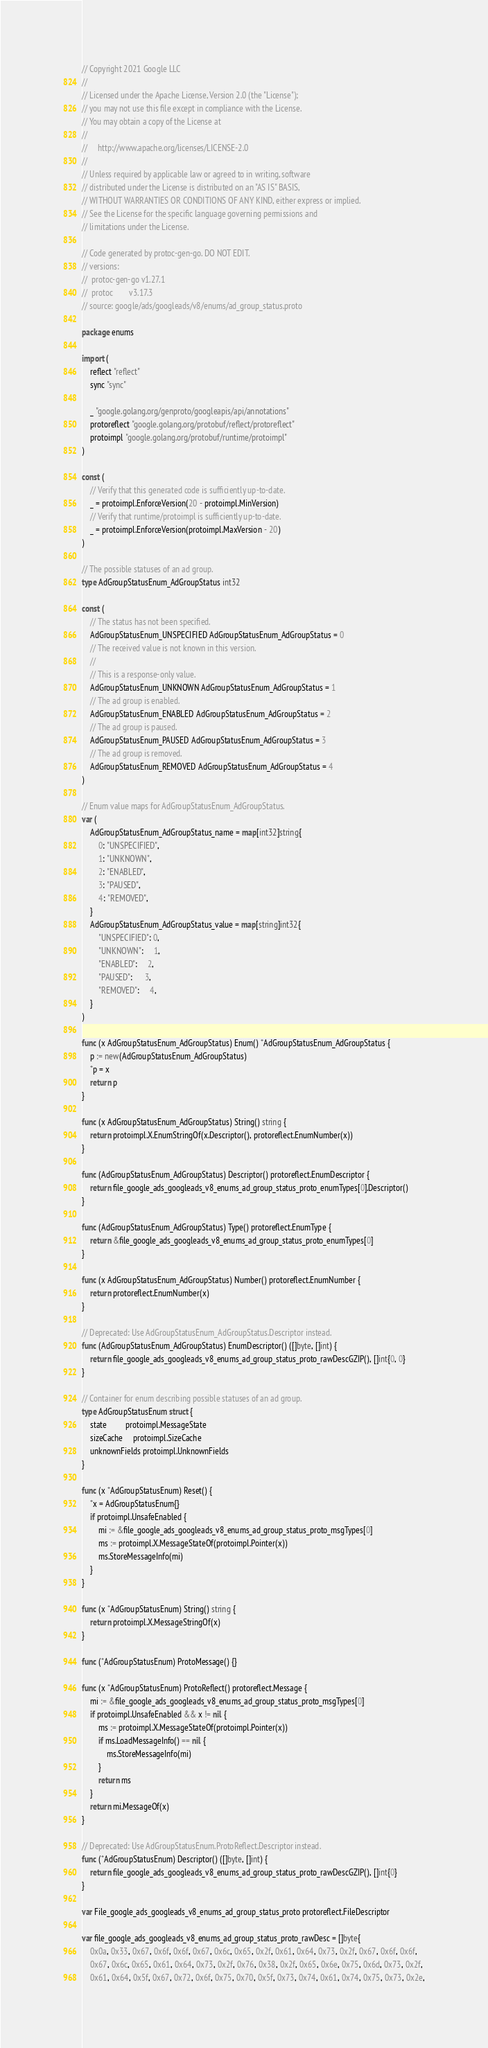Convert code to text. <code><loc_0><loc_0><loc_500><loc_500><_Go_>// Copyright 2021 Google LLC
//
// Licensed under the Apache License, Version 2.0 (the "License");
// you may not use this file except in compliance with the License.
// You may obtain a copy of the License at
//
//     http://www.apache.org/licenses/LICENSE-2.0
//
// Unless required by applicable law or agreed to in writing, software
// distributed under the License is distributed on an "AS IS" BASIS,
// WITHOUT WARRANTIES OR CONDITIONS OF ANY KIND, either express or implied.
// See the License for the specific language governing permissions and
// limitations under the License.

// Code generated by protoc-gen-go. DO NOT EDIT.
// versions:
// 	protoc-gen-go v1.27.1
// 	protoc        v3.17.3
// source: google/ads/googleads/v8/enums/ad_group_status.proto

package enums

import (
	reflect "reflect"
	sync "sync"

	_ "google.golang.org/genproto/googleapis/api/annotations"
	protoreflect "google.golang.org/protobuf/reflect/protoreflect"
	protoimpl "google.golang.org/protobuf/runtime/protoimpl"
)

const (
	// Verify that this generated code is sufficiently up-to-date.
	_ = protoimpl.EnforceVersion(20 - protoimpl.MinVersion)
	// Verify that runtime/protoimpl is sufficiently up-to-date.
	_ = protoimpl.EnforceVersion(protoimpl.MaxVersion - 20)
)

// The possible statuses of an ad group.
type AdGroupStatusEnum_AdGroupStatus int32

const (
	// The status has not been specified.
	AdGroupStatusEnum_UNSPECIFIED AdGroupStatusEnum_AdGroupStatus = 0
	// The received value is not known in this version.
	//
	// This is a response-only value.
	AdGroupStatusEnum_UNKNOWN AdGroupStatusEnum_AdGroupStatus = 1
	// The ad group is enabled.
	AdGroupStatusEnum_ENABLED AdGroupStatusEnum_AdGroupStatus = 2
	// The ad group is paused.
	AdGroupStatusEnum_PAUSED AdGroupStatusEnum_AdGroupStatus = 3
	// The ad group is removed.
	AdGroupStatusEnum_REMOVED AdGroupStatusEnum_AdGroupStatus = 4
)

// Enum value maps for AdGroupStatusEnum_AdGroupStatus.
var (
	AdGroupStatusEnum_AdGroupStatus_name = map[int32]string{
		0: "UNSPECIFIED",
		1: "UNKNOWN",
		2: "ENABLED",
		3: "PAUSED",
		4: "REMOVED",
	}
	AdGroupStatusEnum_AdGroupStatus_value = map[string]int32{
		"UNSPECIFIED": 0,
		"UNKNOWN":     1,
		"ENABLED":     2,
		"PAUSED":      3,
		"REMOVED":     4,
	}
)

func (x AdGroupStatusEnum_AdGroupStatus) Enum() *AdGroupStatusEnum_AdGroupStatus {
	p := new(AdGroupStatusEnum_AdGroupStatus)
	*p = x
	return p
}

func (x AdGroupStatusEnum_AdGroupStatus) String() string {
	return protoimpl.X.EnumStringOf(x.Descriptor(), protoreflect.EnumNumber(x))
}

func (AdGroupStatusEnum_AdGroupStatus) Descriptor() protoreflect.EnumDescriptor {
	return file_google_ads_googleads_v8_enums_ad_group_status_proto_enumTypes[0].Descriptor()
}

func (AdGroupStatusEnum_AdGroupStatus) Type() protoreflect.EnumType {
	return &file_google_ads_googleads_v8_enums_ad_group_status_proto_enumTypes[0]
}

func (x AdGroupStatusEnum_AdGroupStatus) Number() protoreflect.EnumNumber {
	return protoreflect.EnumNumber(x)
}

// Deprecated: Use AdGroupStatusEnum_AdGroupStatus.Descriptor instead.
func (AdGroupStatusEnum_AdGroupStatus) EnumDescriptor() ([]byte, []int) {
	return file_google_ads_googleads_v8_enums_ad_group_status_proto_rawDescGZIP(), []int{0, 0}
}

// Container for enum describing possible statuses of an ad group.
type AdGroupStatusEnum struct {
	state         protoimpl.MessageState
	sizeCache     protoimpl.SizeCache
	unknownFields protoimpl.UnknownFields
}

func (x *AdGroupStatusEnum) Reset() {
	*x = AdGroupStatusEnum{}
	if protoimpl.UnsafeEnabled {
		mi := &file_google_ads_googleads_v8_enums_ad_group_status_proto_msgTypes[0]
		ms := protoimpl.X.MessageStateOf(protoimpl.Pointer(x))
		ms.StoreMessageInfo(mi)
	}
}

func (x *AdGroupStatusEnum) String() string {
	return protoimpl.X.MessageStringOf(x)
}

func (*AdGroupStatusEnum) ProtoMessage() {}

func (x *AdGroupStatusEnum) ProtoReflect() protoreflect.Message {
	mi := &file_google_ads_googleads_v8_enums_ad_group_status_proto_msgTypes[0]
	if protoimpl.UnsafeEnabled && x != nil {
		ms := protoimpl.X.MessageStateOf(protoimpl.Pointer(x))
		if ms.LoadMessageInfo() == nil {
			ms.StoreMessageInfo(mi)
		}
		return ms
	}
	return mi.MessageOf(x)
}

// Deprecated: Use AdGroupStatusEnum.ProtoReflect.Descriptor instead.
func (*AdGroupStatusEnum) Descriptor() ([]byte, []int) {
	return file_google_ads_googleads_v8_enums_ad_group_status_proto_rawDescGZIP(), []int{0}
}

var File_google_ads_googleads_v8_enums_ad_group_status_proto protoreflect.FileDescriptor

var file_google_ads_googleads_v8_enums_ad_group_status_proto_rawDesc = []byte{
	0x0a, 0x33, 0x67, 0x6f, 0x6f, 0x67, 0x6c, 0x65, 0x2f, 0x61, 0x64, 0x73, 0x2f, 0x67, 0x6f, 0x6f,
	0x67, 0x6c, 0x65, 0x61, 0x64, 0x73, 0x2f, 0x76, 0x38, 0x2f, 0x65, 0x6e, 0x75, 0x6d, 0x73, 0x2f,
	0x61, 0x64, 0x5f, 0x67, 0x72, 0x6f, 0x75, 0x70, 0x5f, 0x73, 0x74, 0x61, 0x74, 0x75, 0x73, 0x2e,</code> 